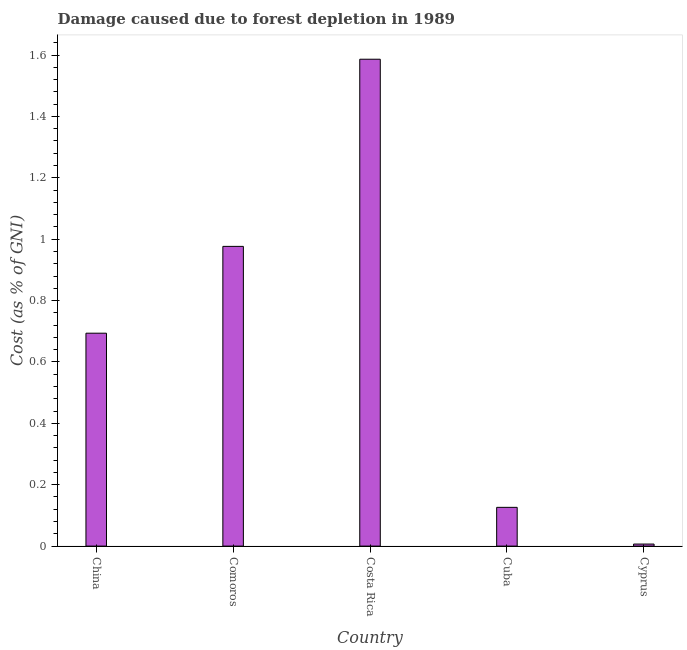Does the graph contain any zero values?
Offer a terse response. No. Does the graph contain grids?
Your answer should be compact. No. What is the title of the graph?
Give a very brief answer. Damage caused due to forest depletion in 1989. What is the label or title of the X-axis?
Keep it short and to the point. Country. What is the label or title of the Y-axis?
Your response must be concise. Cost (as % of GNI). What is the damage caused due to forest depletion in Costa Rica?
Provide a short and direct response. 1.59. Across all countries, what is the maximum damage caused due to forest depletion?
Your response must be concise. 1.59. Across all countries, what is the minimum damage caused due to forest depletion?
Your answer should be compact. 0.01. In which country was the damage caused due to forest depletion maximum?
Ensure brevity in your answer.  Costa Rica. In which country was the damage caused due to forest depletion minimum?
Give a very brief answer. Cyprus. What is the sum of the damage caused due to forest depletion?
Your answer should be compact. 3.39. What is the difference between the damage caused due to forest depletion in China and Comoros?
Your response must be concise. -0.28. What is the average damage caused due to forest depletion per country?
Offer a terse response. 0.68. What is the median damage caused due to forest depletion?
Your answer should be very brief. 0.69. What is the ratio of the damage caused due to forest depletion in China to that in Cuba?
Offer a terse response. 5.5. Is the damage caused due to forest depletion in Comoros less than that in Costa Rica?
Ensure brevity in your answer.  Yes. What is the difference between the highest and the second highest damage caused due to forest depletion?
Provide a succinct answer. 0.61. Is the sum of the damage caused due to forest depletion in Comoros and Costa Rica greater than the maximum damage caused due to forest depletion across all countries?
Offer a terse response. Yes. What is the difference between the highest and the lowest damage caused due to forest depletion?
Your answer should be compact. 1.58. How many bars are there?
Your response must be concise. 5. How many countries are there in the graph?
Ensure brevity in your answer.  5. What is the difference between two consecutive major ticks on the Y-axis?
Make the answer very short. 0.2. Are the values on the major ticks of Y-axis written in scientific E-notation?
Your answer should be compact. No. What is the Cost (as % of GNI) in China?
Offer a terse response. 0.69. What is the Cost (as % of GNI) in Comoros?
Provide a succinct answer. 0.98. What is the Cost (as % of GNI) in Costa Rica?
Keep it short and to the point. 1.59. What is the Cost (as % of GNI) in Cuba?
Ensure brevity in your answer.  0.13. What is the Cost (as % of GNI) in Cyprus?
Ensure brevity in your answer.  0.01. What is the difference between the Cost (as % of GNI) in China and Comoros?
Offer a very short reply. -0.28. What is the difference between the Cost (as % of GNI) in China and Costa Rica?
Provide a succinct answer. -0.89. What is the difference between the Cost (as % of GNI) in China and Cuba?
Keep it short and to the point. 0.57. What is the difference between the Cost (as % of GNI) in China and Cyprus?
Make the answer very short. 0.69. What is the difference between the Cost (as % of GNI) in Comoros and Costa Rica?
Offer a terse response. -0.61. What is the difference between the Cost (as % of GNI) in Comoros and Cuba?
Make the answer very short. 0.85. What is the difference between the Cost (as % of GNI) in Comoros and Cyprus?
Your response must be concise. 0.97. What is the difference between the Cost (as % of GNI) in Costa Rica and Cuba?
Your answer should be compact. 1.46. What is the difference between the Cost (as % of GNI) in Costa Rica and Cyprus?
Keep it short and to the point. 1.58. What is the difference between the Cost (as % of GNI) in Cuba and Cyprus?
Your answer should be very brief. 0.12. What is the ratio of the Cost (as % of GNI) in China to that in Comoros?
Provide a short and direct response. 0.71. What is the ratio of the Cost (as % of GNI) in China to that in Costa Rica?
Offer a very short reply. 0.44. What is the ratio of the Cost (as % of GNI) in China to that in Cuba?
Your response must be concise. 5.5. What is the ratio of the Cost (as % of GNI) in China to that in Cyprus?
Your answer should be very brief. 103.85. What is the ratio of the Cost (as % of GNI) in Comoros to that in Costa Rica?
Make the answer very short. 0.62. What is the ratio of the Cost (as % of GNI) in Comoros to that in Cuba?
Your answer should be very brief. 7.74. What is the ratio of the Cost (as % of GNI) in Comoros to that in Cyprus?
Provide a short and direct response. 146.2. What is the ratio of the Cost (as % of GNI) in Costa Rica to that in Cuba?
Provide a succinct answer. 12.57. What is the ratio of the Cost (as % of GNI) in Costa Rica to that in Cyprus?
Provide a short and direct response. 237.5. What is the ratio of the Cost (as % of GNI) in Cuba to that in Cyprus?
Keep it short and to the point. 18.9. 